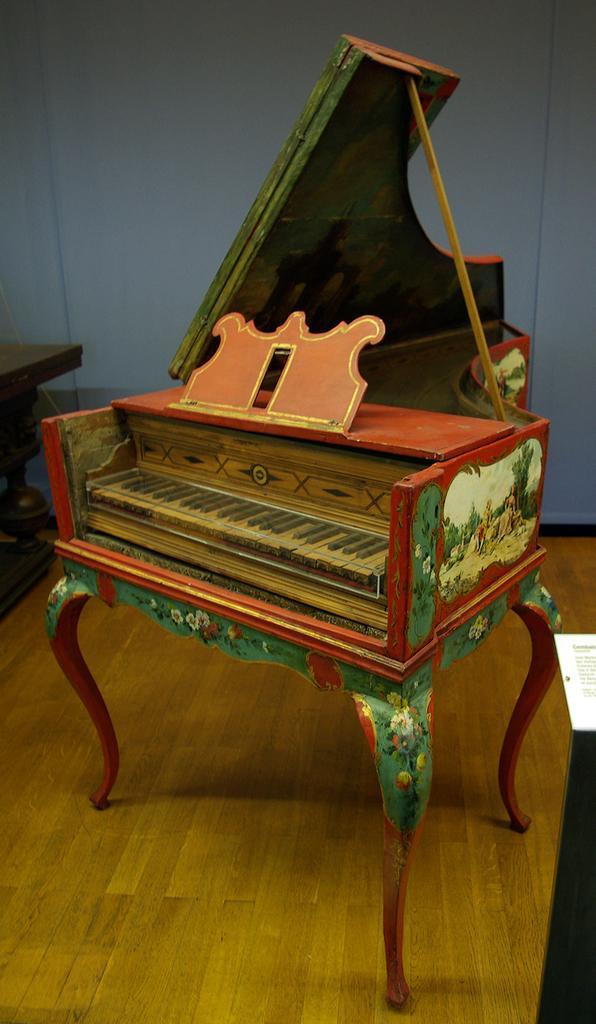Can you describe this image briefly? This picture shows a piano 